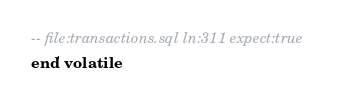<code> <loc_0><loc_0><loc_500><loc_500><_SQL_>-- file:transactions.sql ln:311 expect:true
end' volatile
</code> 